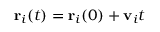<formula> <loc_0><loc_0><loc_500><loc_500>{ r } _ { i } ( t ) = { r } _ { i } ( 0 ) + { v } _ { i } t</formula> 